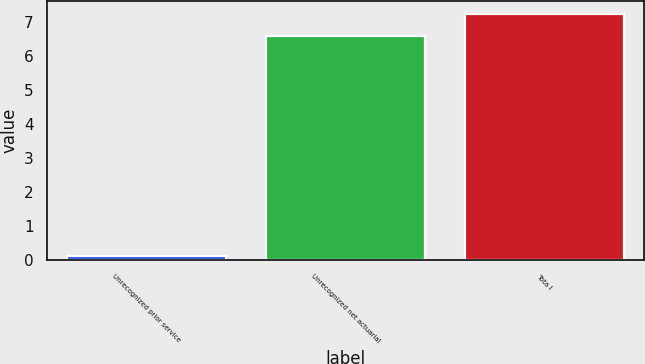<chart> <loc_0><loc_0><loc_500><loc_500><bar_chart><fcel>Unrecognized prior service<fcel>Unrecognized net actuarial<fcel>Tota l<nl><fcel>0.1<fcel>6.6<fcel>7.26<nl></chart> 